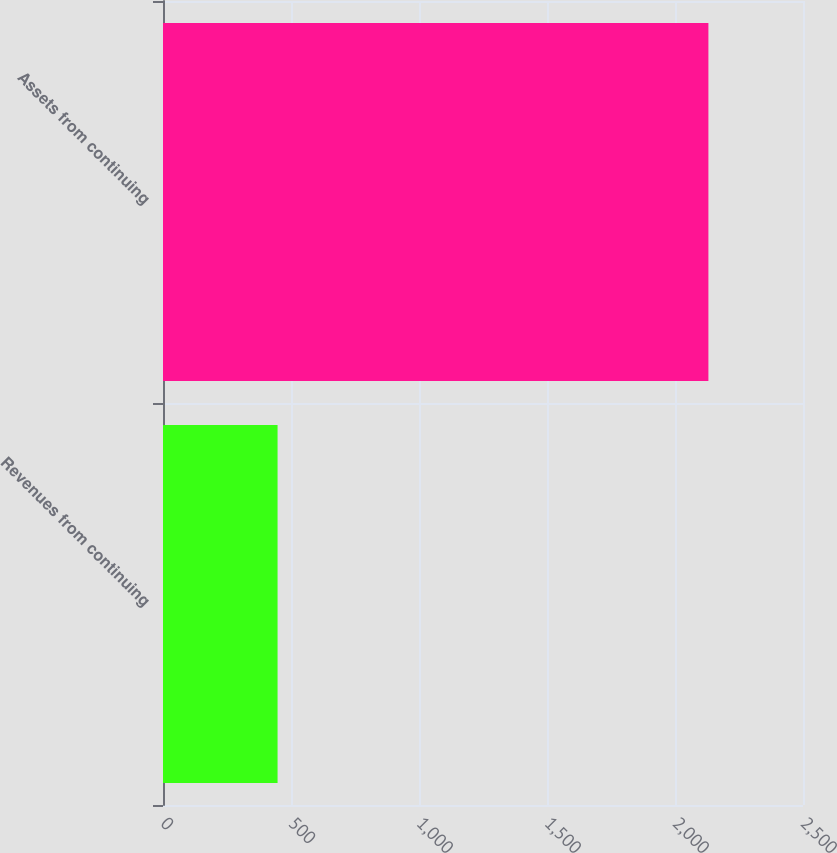<chart> <loc_0><loc_0><loc_500><loc_500><bar_chart><fcel>Revenues from continuing<fcel>Assets from continuing<nl><fcel>447.5<fcel>2130.5<nl></chart> 